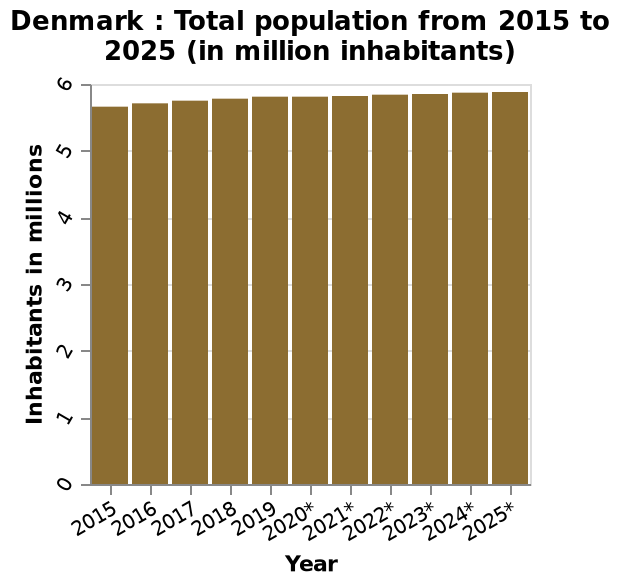<image>
What is the estimated population of Denmark for 2025?  The estimated population of Denmark for 2025 is approximately 5.85 million. How has the population of Denmark been increasing since 2015?  The population of Denmark has been experiencing a consistent but slow increase since 2015. Has the population of Denmark been experiencing a consistent but rapid decrease since 2015? No. The population of Denmark has been experiencing a consistent but slow increase since 2015. 